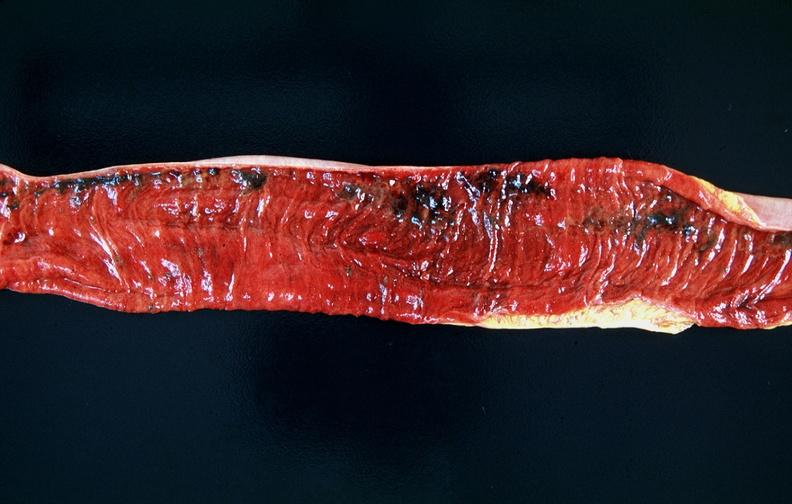s gastrointestinal present?
Answer the question using a single word or phrase. Yes 